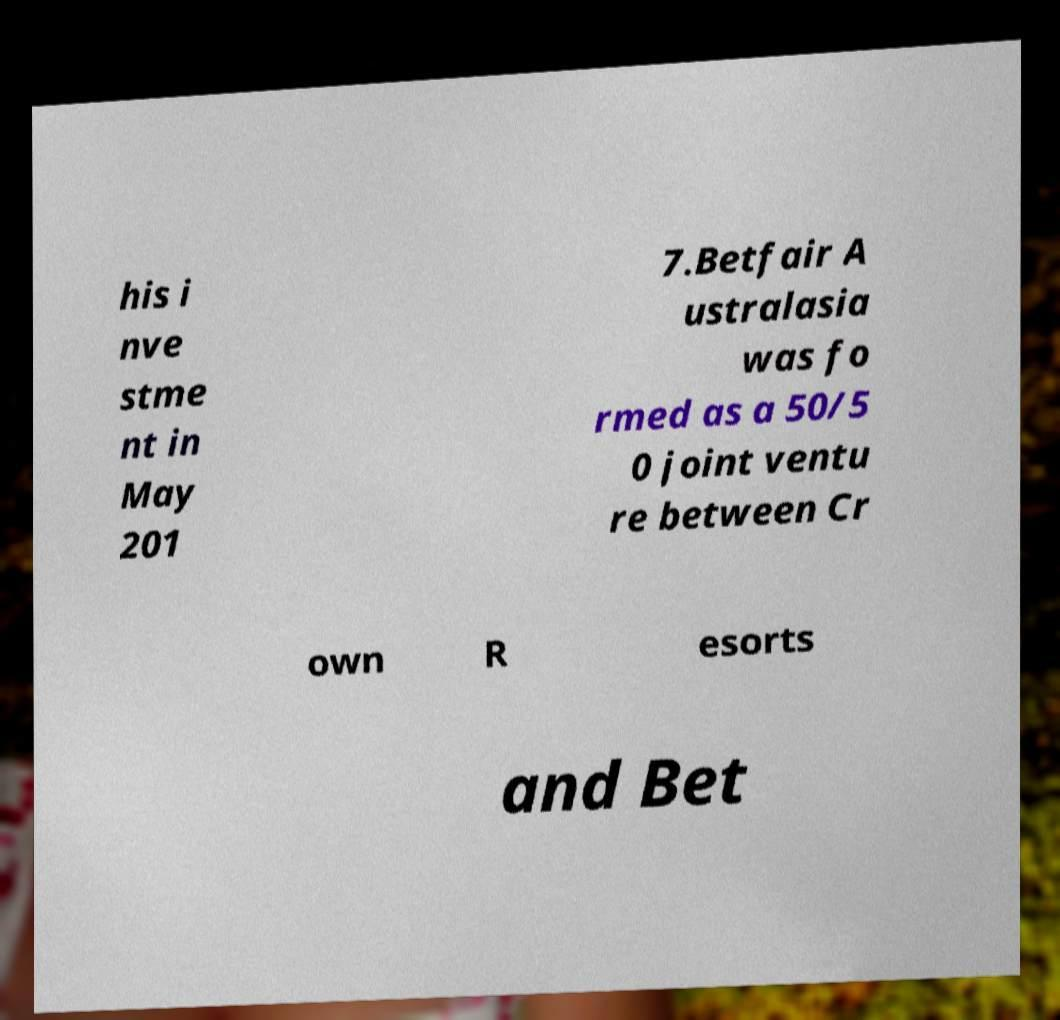Can you read and provide the text displayed in the image?This photo seems to have some interesting text. Can you extract and type it out for me? his i nve stme nt in May 201 7.Betfair A ustralasia was fo rmed as a 50/5 0 joint ventu re between Cr own R esorts and Bet 